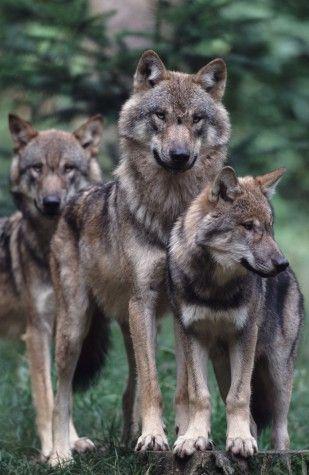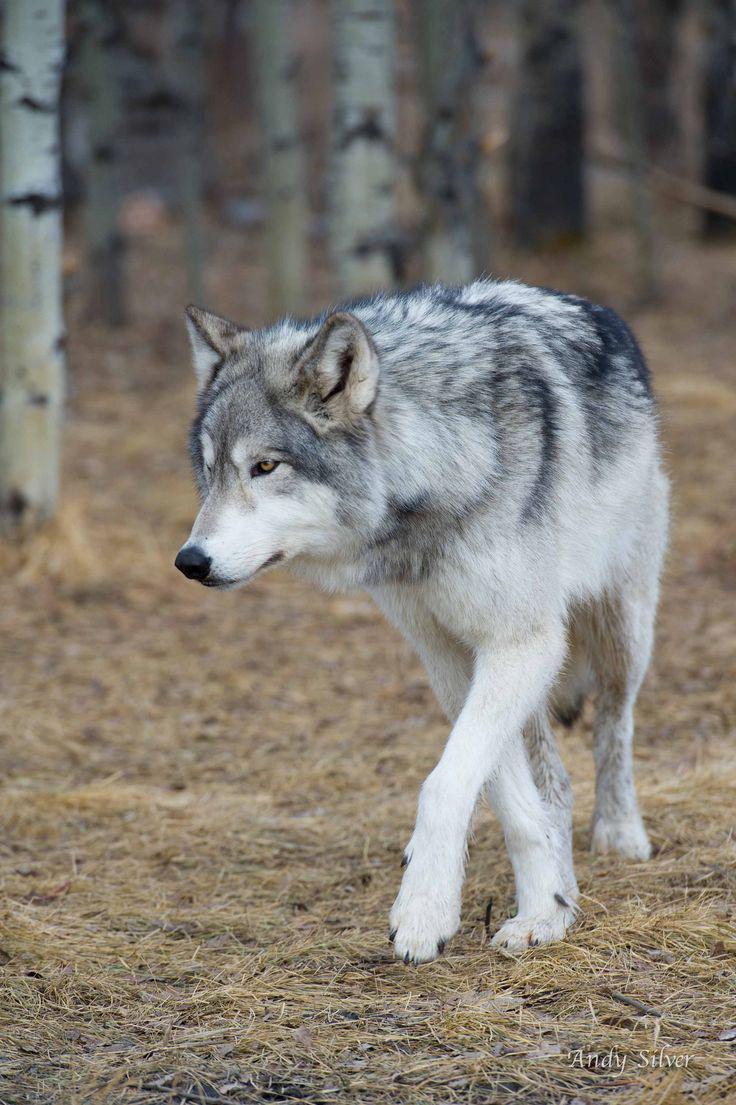The first image is the image on the left, the second image is the image on the right. Analyze the images presented: Is the assertion "There is exactly one animal with its mouth open in one of the images." valid? Answer yes or no. No. 